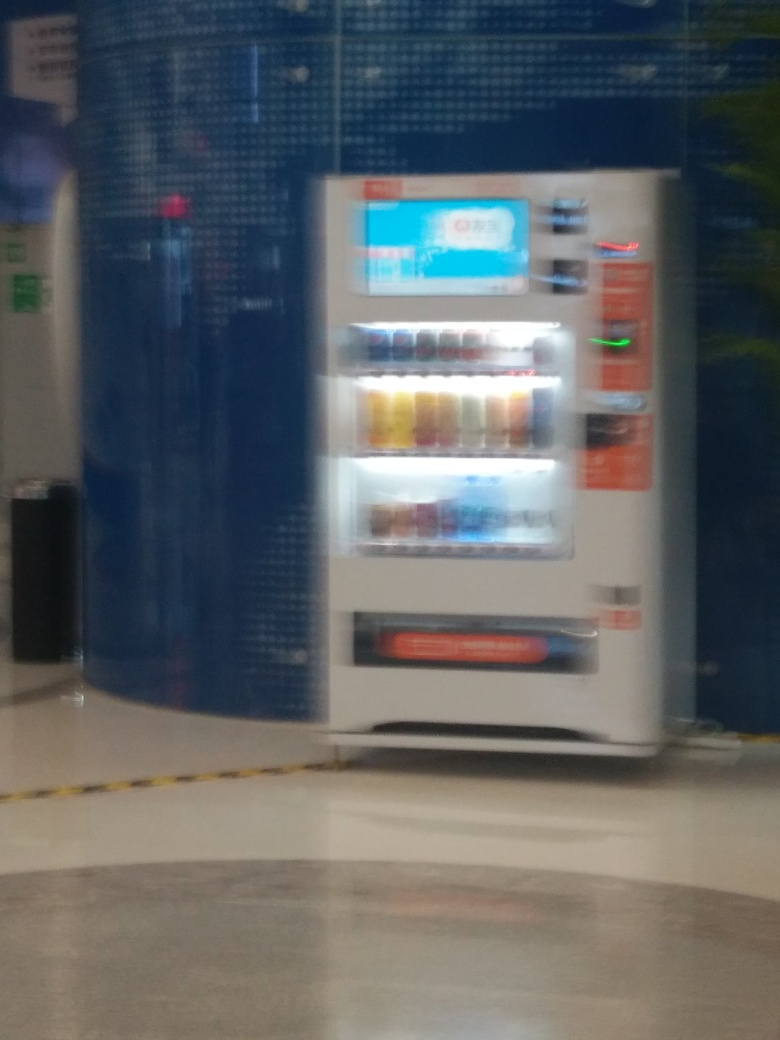What is the overall quality of the image? The overall quality of the image is quite poor. It's blurry and lacks detail, making it difficult to clearly discern specific features or objects within. 